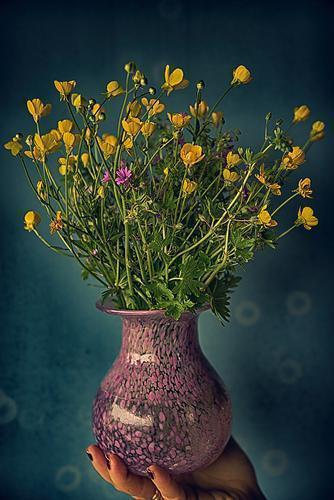How many vases are there?
Give a very brief answer. 1. 